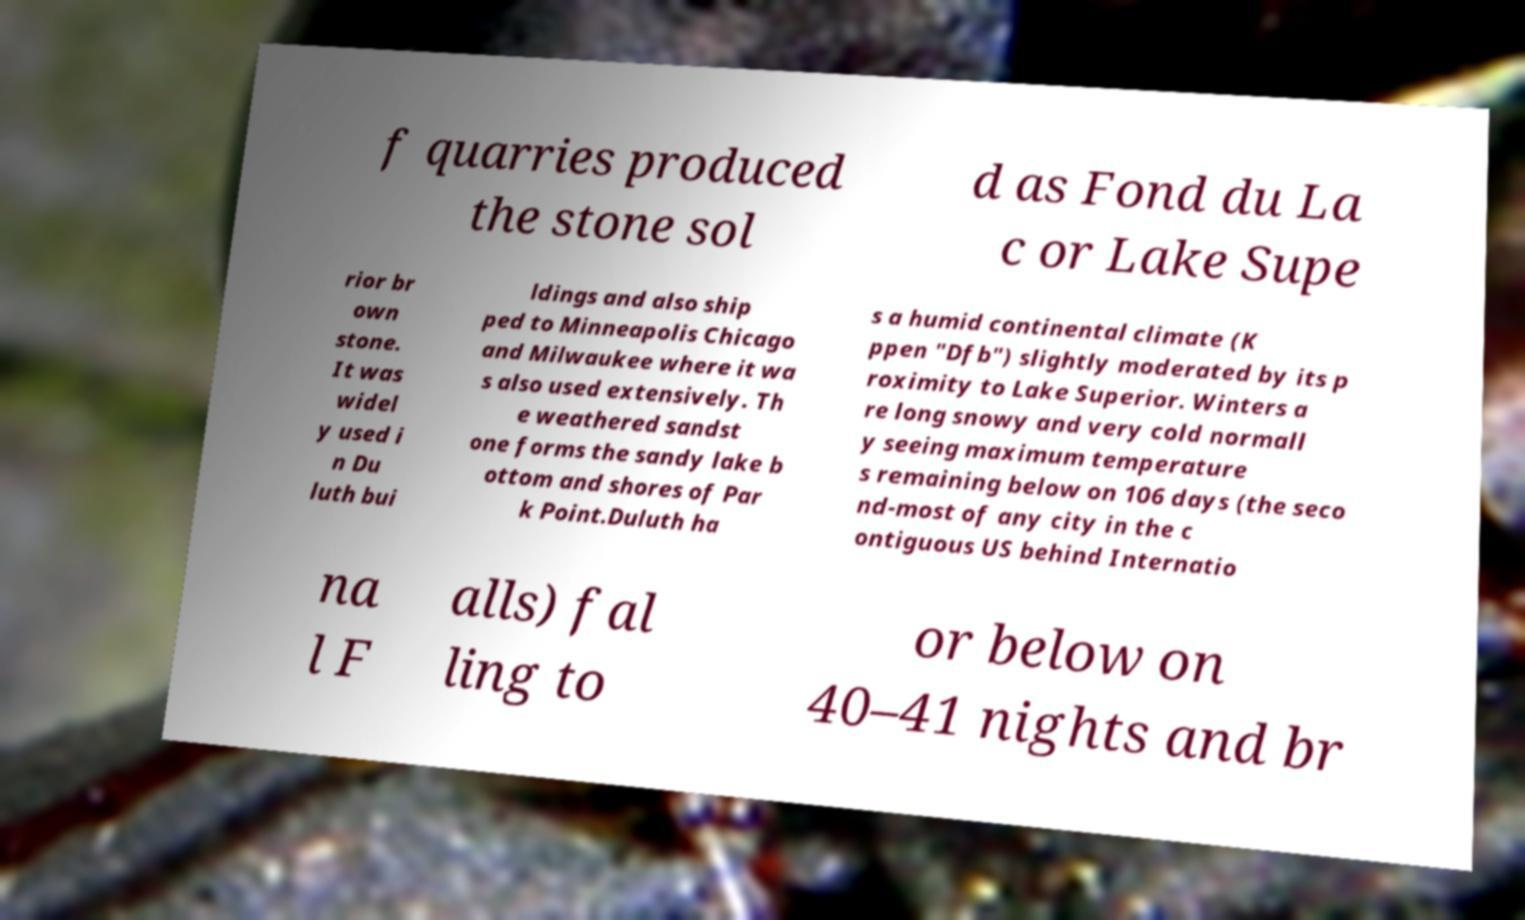What messages or text are displayed in this image? I need them in a readable, typed format. f quarries produced the stone sol d as Fond du La c or Lake Supe rior br own stone. It was widel y used i n Du luth bui ldings and also ship ped to Minneapolis Chicago and Milwaukee where it wa s also used extensively. Th e weathered sandst one forms the sandy lake b ottom and shores of Par k Point.Duluth ha s a humid continental climate (K ppen "Dfb") slightly moderated by its p roximity to Lake Superior. Winters a re long snowy and very cold normall y seeing maximum temperature s remaining below on 106 days (the seco nd-most of any city in the c ontiguous US behind Internatio na l F alls) fal ling to or below on 40–41 nights and br 